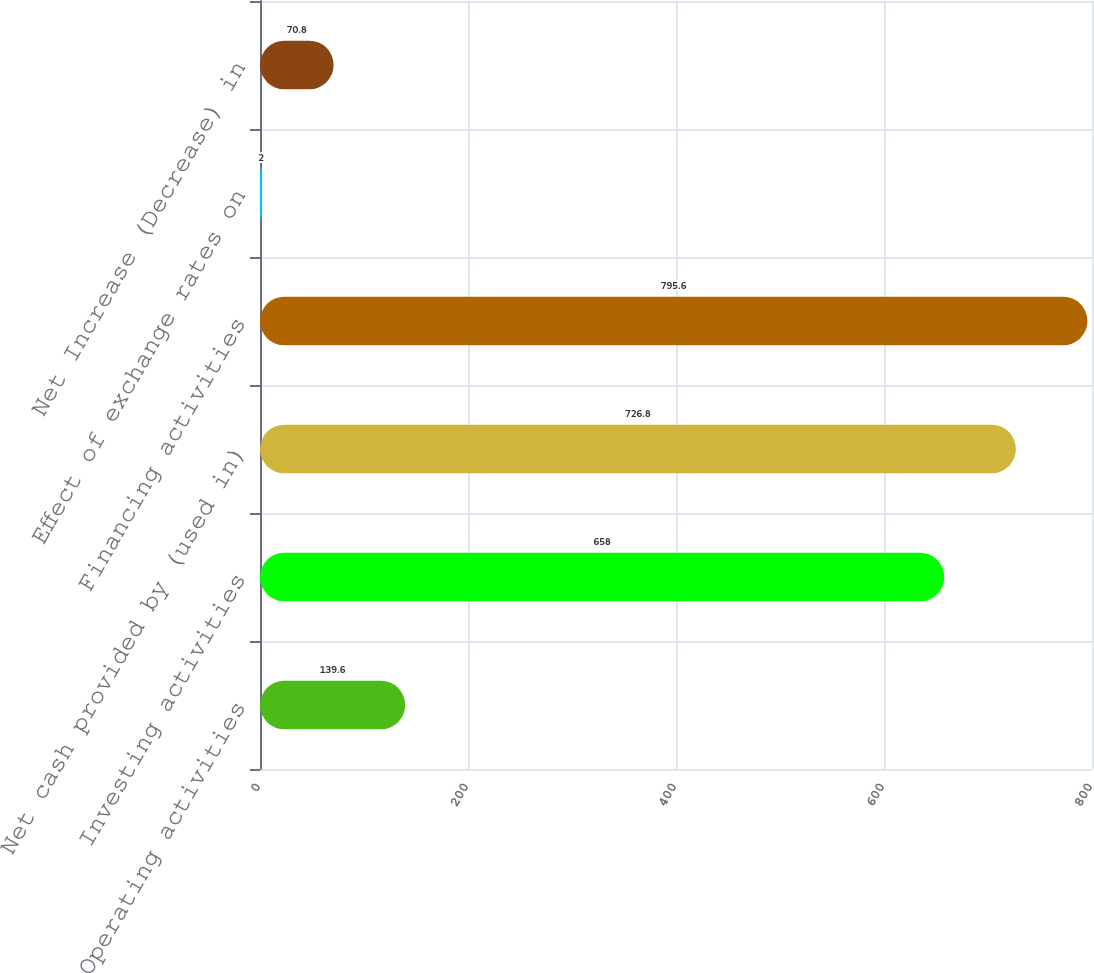Convert chart. <chart><loc_0><loc_0><loc_500><loc_500><bar_chart><fcel>Operating activities<fcel>Investing activities<fcel>Net cash provided by (used in)<fcel>Financing activities<fcel>Effect of exchange rates on<fcel>Net Increase (Decrease) in<nl><fcel>139.6<fcel>658<fcel>726.8<fcel>795.6<fcel>2<fcel>70.8<nl></chart> 